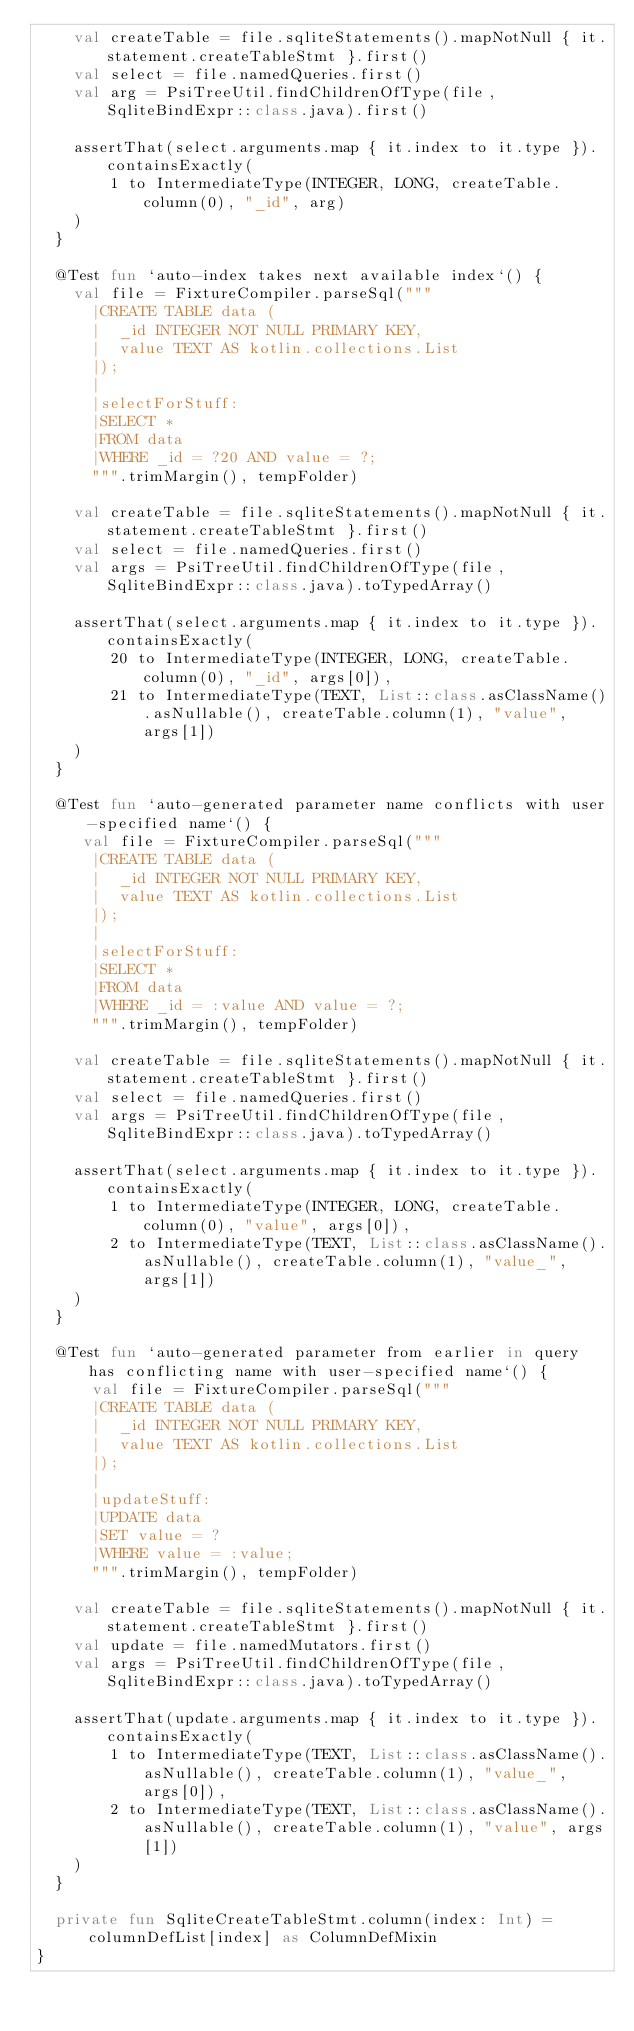Convert code to text. <code><loc_0><loc_0><loc_500><loc_500><_Kotlin_>    val createTable = file.sqliteStatements().mapNotNull { it.statement.createTableStmt }.first()
    val select = file.namedQueries.first()
    val arg = PsiTreeUtil.findChildrenOfType(file, SqliteBindExpr::class.java).first()

    assertThat(select.arguments.map { it.index to it.type }).containsExactly(
        1 to IntermediateType(INTEGER, LONG, createTable.column(0), "_id", arg)
    )
  }

  @Test fun `auto-index takes next available index`() {
    val file = FixtureCompiler.parseSql("""
      |CREATE TABLE data (
      |  _id INTEGER NOT NULL PRIMARY KEY,
      |  value TEXT AS kotlin.collections.List
      |);
      |
      |selectForStuff:
      |SELECT *
      |FROM data
      |WHERE _id = ?20 AND value = ?;
      """.trimMargin(), tempFolder)

    val createTable = file.sqliteStatements().mapNotNull { it.statement.createTableStmt }.first()
    val select = file.namedQueries.first()
    val args = PsiTreeUtil.findChildrenOfType(file, SqliteBindExpr::class.java).toTypedArray()

    assertThat(select.arguments.map { it.index to it.type }).containsExactly(
        20 to IntermediateType(INTEGER, LONG, createTable.column(0), "_id", args[0]),
        21 to IntermediateType(TEXT, List::class.asClassName().asNullable(), createTable.column(1), "value", args[1])
    )
  }

  @Test fun `auto-generated parameter name conflicts with user-specified name`() {
     val file = FixtureCompiler.parseSql("""
      |CREATE TABLE data (
      |  _id INTEGER NOT NULL PRIMARY KEY,
      |  value TEXT AS kotlin.collections.List
      |);
      |
      |selectForStuff:
      |SELECT *
      |FROM data
      |WHERE _id = :value AND value = ?;
      """.trimMargin(), tempFolder)

    val createTable = file.sqliteStatements().mapNotNull { it.statement.createTableStmt }.first()
    val select = file.namedQueries.first()
    val args = PsiTreeUtil.findChildrenOfType(file, SqliteBindExpr::class.java).toTypedArray()

    assertThat(select.arguments.map { it.index to it.type }).containsExactly(
        1 to IntermediateType(INTEGER, LONG, createTable.column(0), "value", args[0]),
        2 to IntermediateType(TEXT, List::class.asClassName().asNullable(), createTable.column(1), "value_", args[1])
    )
  }

  @Test fun `auto-generated parameter from earlier in query has conflicting name with user-specified name`() {
      val file = FixtureCompiler.parseSql("""
      |CREATE TABLE data (
      |  _id INTEGER NOT NULL PRIMARY KEY,
      |  value TEXT AS kotlin.collections.List
      |);
      |
      |updateStuff:
      |UPDATE data
      |SET value = ?
      |WHERE value = :value;
      """.trimMargin(), tempFolder)

    val createTable = file.sqliteStatements().mapNotNull { it.statement.createTableStmt }.first()
    val update = file.namedMutators.first()
    val args = PsiTreeUtil.findChildrenOfType(file, SqliteBindExpr::class.java).toTypedArray()

    assertThat(update.arguments.map { it.index to it.type }).containsExactly(
        1 to IntermediateType(TEXT, List::class.asClassName().asNullable(), createTable.column(1), "value_", args[0]),
        2 to IntermediateType(TEXT, List::class.asClassName().asNullable(), createTable.column(1), "value", args[1])
    )
  }

  private fun SqliteCreateTableStmt.column(index: Int) = columnDefList[index] as ColumnDefMixin
}</code> 